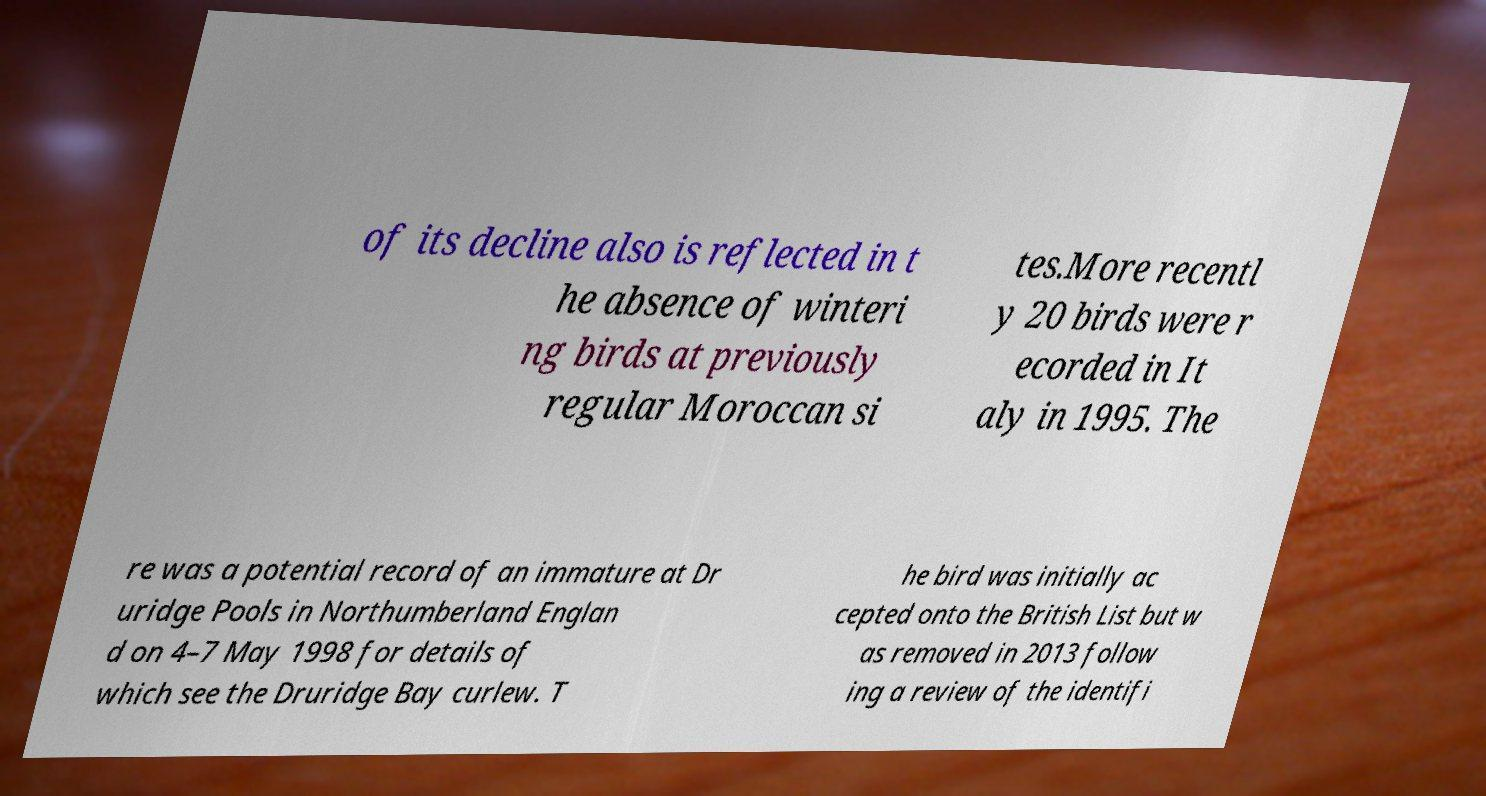Please identify and transcribe the text found in this image. of its decline also is reflected in t he absence of winteri ng birds at previously regular Moroccan si tes.More recentl y 20 birds were r ecorded in It aly in 1995. The re was a potential record of an immature at Dr uridge Pools in Northumberland Englan d on 4–7 May 1998 for details of which see the Druridge Bay curlew. T he bird was initially ac cepted onto the British List but w as removed in 2013 follow ing a review of the identifi 